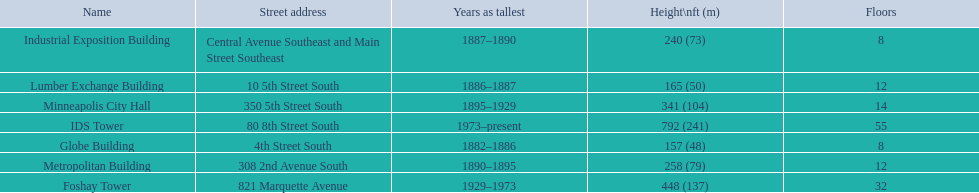What are all the building names? Globe Building, Lumber Exchange Building, Industrial Exposition Building, Metropolitan Building, Minneapolis City Hall, Foshay Tower, IDS Tower. And their heights? 157 (48), 165 (50), 240 (73), 258 (79), 341 (104), 448 (137), 792 (241). Between metropolitan building and lumber exchange building, which is taller? Metropolitan Building. 